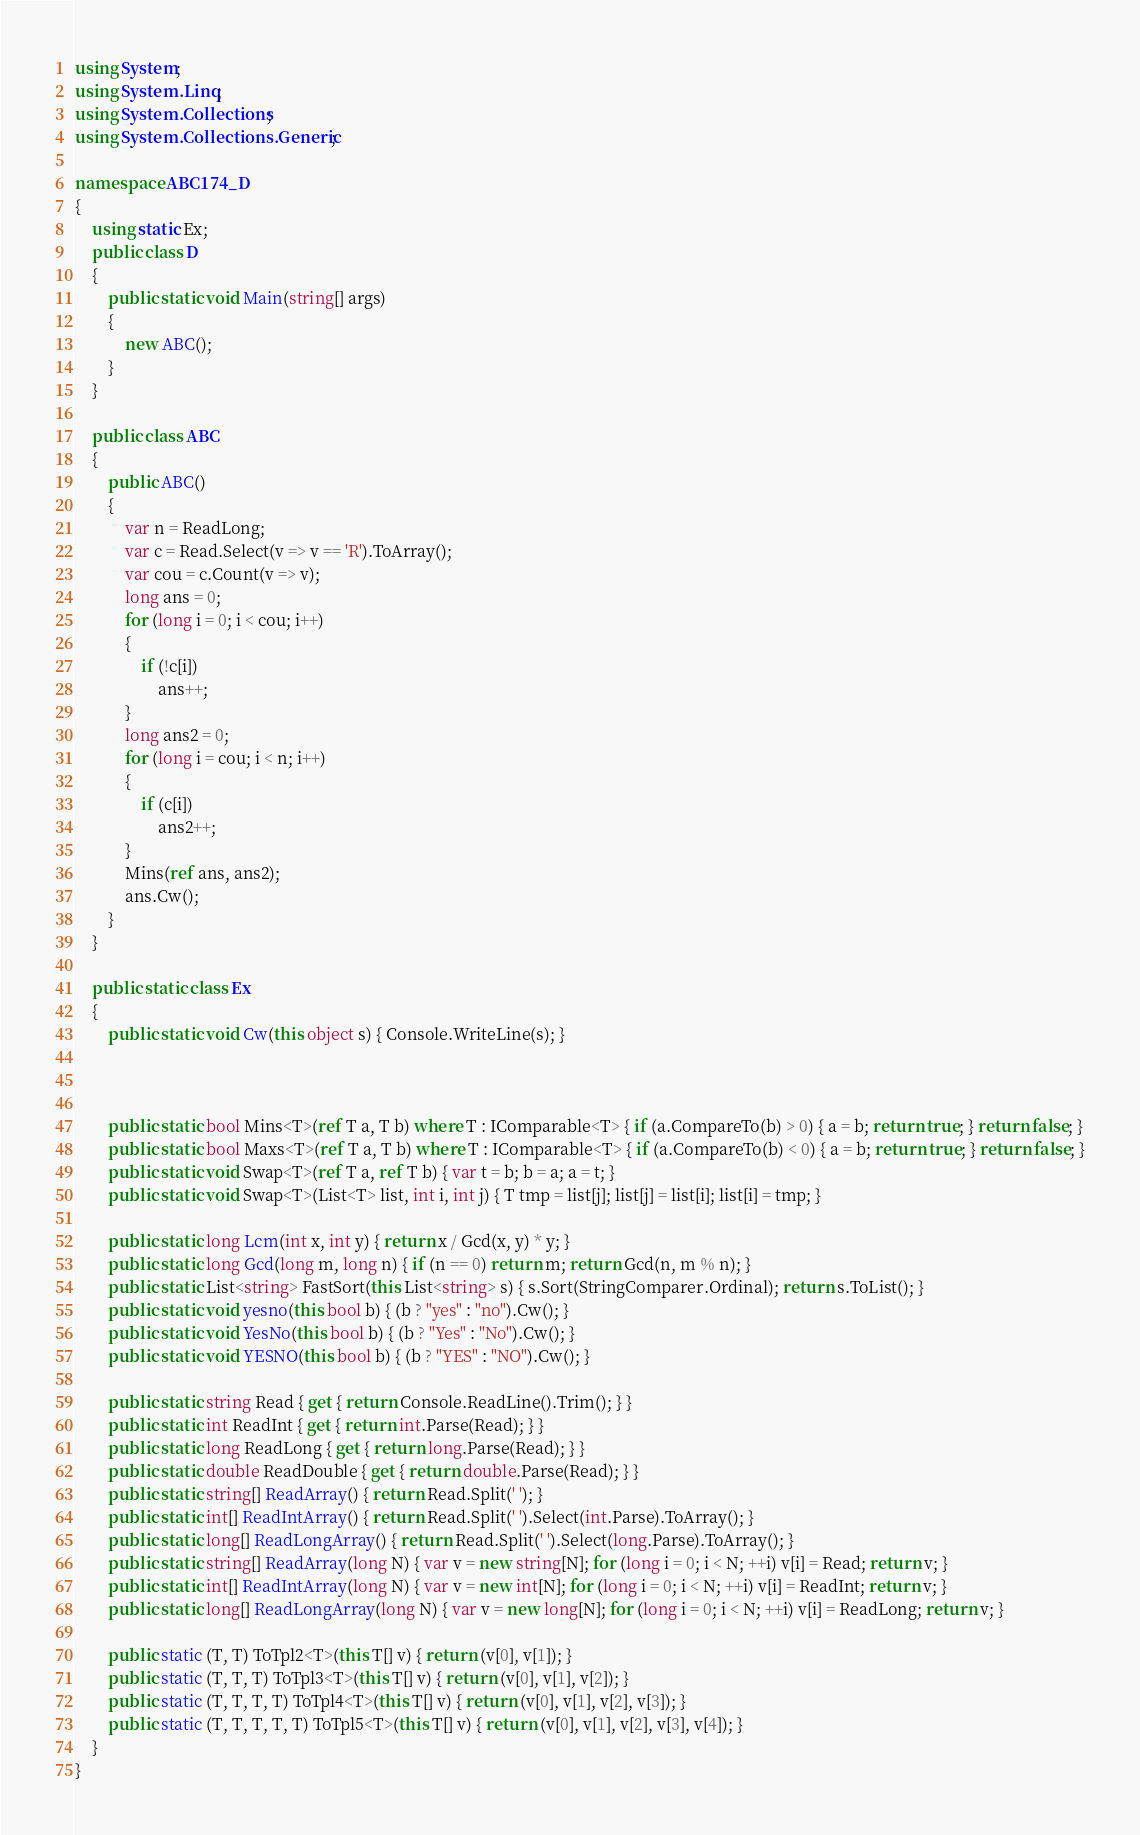<code> <loc_0><loc_0><loc_500><loc_500><_C#_>using System;
using System.Linq;
using System.Collections;
using System.Collections.Generic;

namespace ABC174_D
{
    using static Ex;
    public class D
    {
        public static void Main(string[] args)
        {
            new ABC();
        }
    }

    public class ABC
    {
        public ABC()
        {
            var n = ReadLong;
            var c = Read.Select(v => v == 'R').ToArray();
            var cou = c.Count(v => v);
            long ans = 0;
            for (long i = 0; i < cou; i++)
            {
                if (!c[i])
                    ans++;
            }
            long ans2 = 0;
            for (long i = cou; i < n; i++)
            {
                if (c[i])
                    ans2++;
            }
            Mins(ref ans, ans2);
            ans.Cw();
        }
    }

    public static class Ex
    {
        public static void Cw(this object s) { Console.WriteLine(s); }



        public static bool Mins<T>(ref T a, T b) where T : IComparable<T> { if (a.CompareTo(b) > 0) { a = b; return true; } return false; }
        public static bool Maxs<T>(ref T a, T b) where T : IComparable<T> { if (a.CompareTo(b) < 0) { a = b; return true; } return false; }
        public static void Swap<T>(ref T a, ref T b) { var t = b; b = a; a = t; }
        public static void Swap<T>(List<T> list, int i, int j) { T tmp = list[j]; list[j] = list[i]; list[i] = tmp; }

        public static long Lcm(int x, int y) { return x / Gcd(x, y) * y; }
        public static long Gcd(long m, long n) { if (n == 0) return m; return Gcd(n, m % n); }
        public static List<string> FastSort(this List<string> s) { s.Sort(StringComparer.Ordinal); return s.ToList(); }
        public static void yesno(this bool b) { (b ? "yes" : "no").Cw(); }
        public static void YesNo(this bool b) { (b ? "Yes" : "No").Cw(); }
        public static void YESNO(this bool b) { (b ? "YES" : "NO").Cw(); }

        public static string Read { get { return Console.ReadLine().Trim(); } }
        public static int ReadInt { get { return int.Parse(Read); } }
        public static long ReadLong { get { return long.Parse(Read); } }
        public static double ReadDouble { get { return double.Parse(Read); } }
        public static string[] ReadArray() { return Read.Split(' '); }
        public static int[] ReadIntArray() { return Read.Split(' ').Select(int.Parse).ToArray(); }
        public static long[] ReadLongArray() { return Read.Split(' ').Select(long.Parse).ToArray(); }
        public static string[] ReadArray(long N) { var v = new string[N]; for (long i = 0; i < N; ++i) v[i] = Read; return v; }
        public static int[] ReadIntArray(long N) { var v = new int[N]; for (long i = 0; i < N; ++i) v[i] = ReadInt; return v; }
        public static long[] ReadLongArray(long N) { var v = new long[N]; for (long i = 0; i < N; ++i) v[i] = ReadLong; return v; }

        public static (T, T) ToTpl2<T>(this T[] v) { return (v[0], v[1]); }
        public static (T, T, T) ToTpl3<T>(this T[] v) { return (v[0], v[1], v[2]); }
        public static (T, T, T, T) ToTpl4<T>(this T[] v) { return (v[0], v[1], v[2], v[3]); }
        public static (T, T, T, T, T) ToTpl5<T>(this T[] v) { return (v[0], v[1], v[2], v[3], v[4]); }
    }
}
</code> 